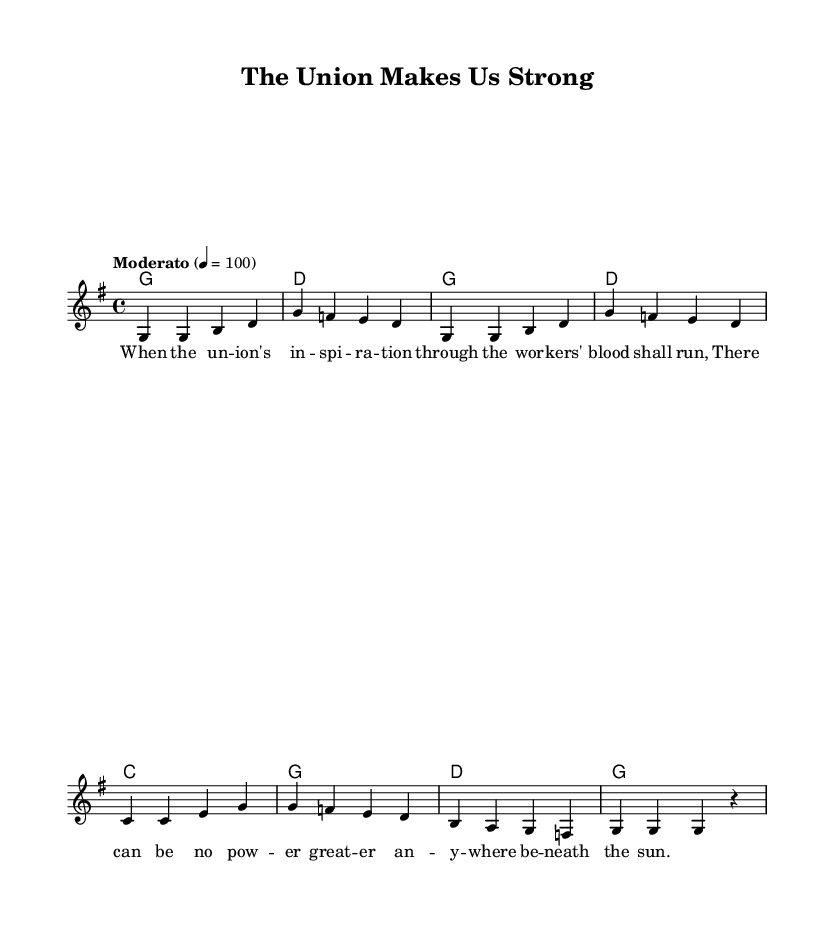What is the key signature of this music? The key signature is G major, which has one sharp. This is indicated at the beginning of the sheet music where the key signature is placed.
Answer: G major What is the time signature of this music? The time signature is 4/4, which is displayed at the beginning of the sheet music right after the key signature. It means there are four beats in each measure and the quarter note gets one beat.
Answer: 4/4 What is the tempo marking of this music? The tempo marking is Moderato, which is shown above the beginning of the music. This indicates a moderate speed for the performance.
Answer: Moderato How many measures are in the melody? The melody consists of eight measures, which can be counted by the distinct groups of notes separated by vertical lines on the staff.
Answer: Eight What is the first note of the melody? The first note of the melody is G, which is the first note shown in the melody line at the start of the first measure.
Answer: G What chord is used in the first measure? The chord used in the first measure is G major, which can be identified from the chord changes indicated in the ChordNames section.
Answer: G What is the lyrical theme of the song? The lyrical theme revolves around union and strength, as derived from the provided verse lyrics that mention the workers' spirit and power.
Answer: Union strength 